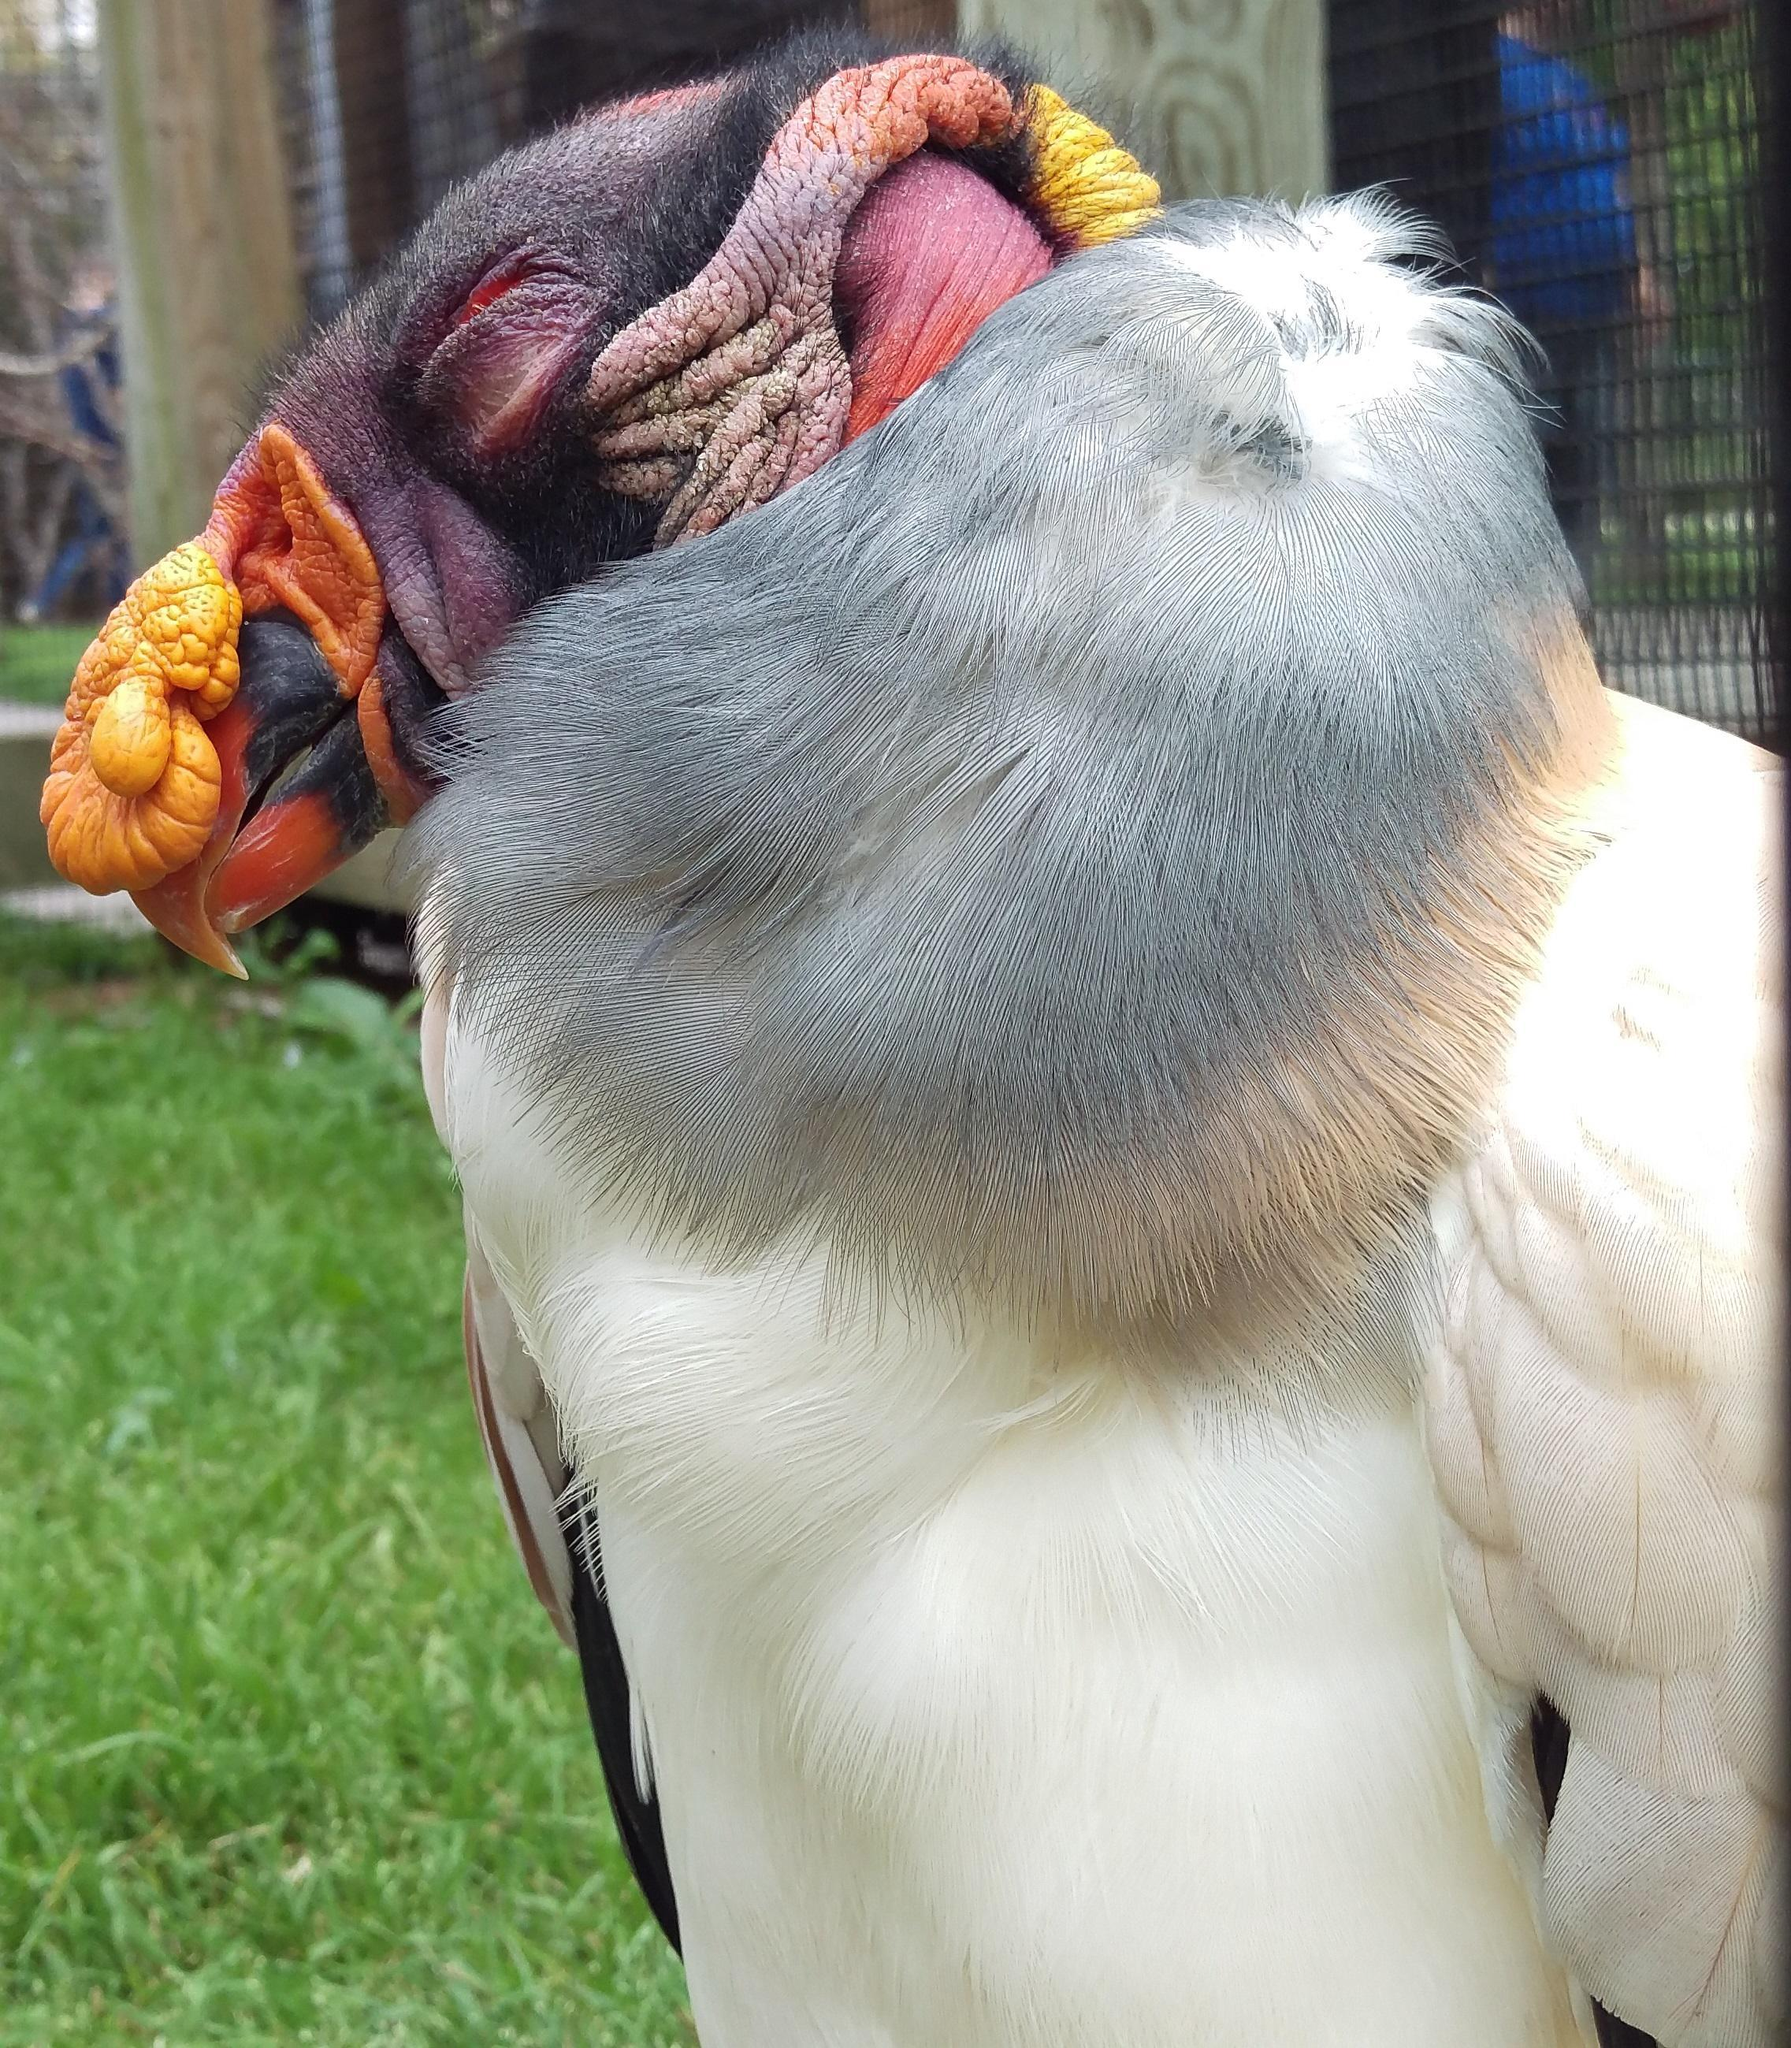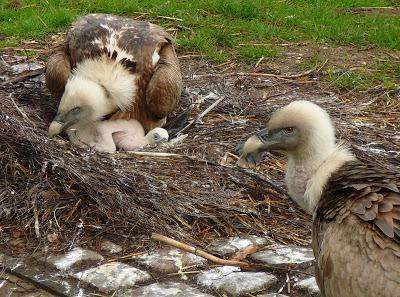The first image is the image on the left, the second image is the image on the right. Given the left and right images, does the statement "One of the birds is perched in a tree branch." hold true? Answer yes or no. No. The first image is the image on the left, the second image is the image on the right. Assess this claim about the two images: "In one of the images the bird is perched on a large branch.". Correct or not? Answer yes or no. No. 